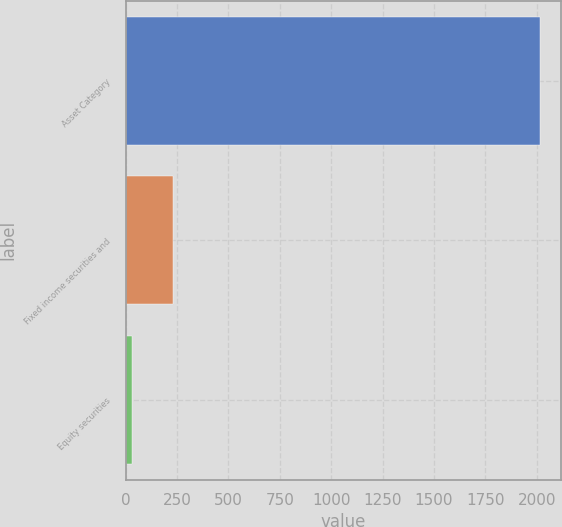<chart> <loc_0><loc_0><loc_500><loc_500><bar_chart><fcel>Asset Category<fcel>Fixed income securities and<fcel>Equity securities<nl><fcel>2015<fcel>228.5<fcel>30<nl></chart> 